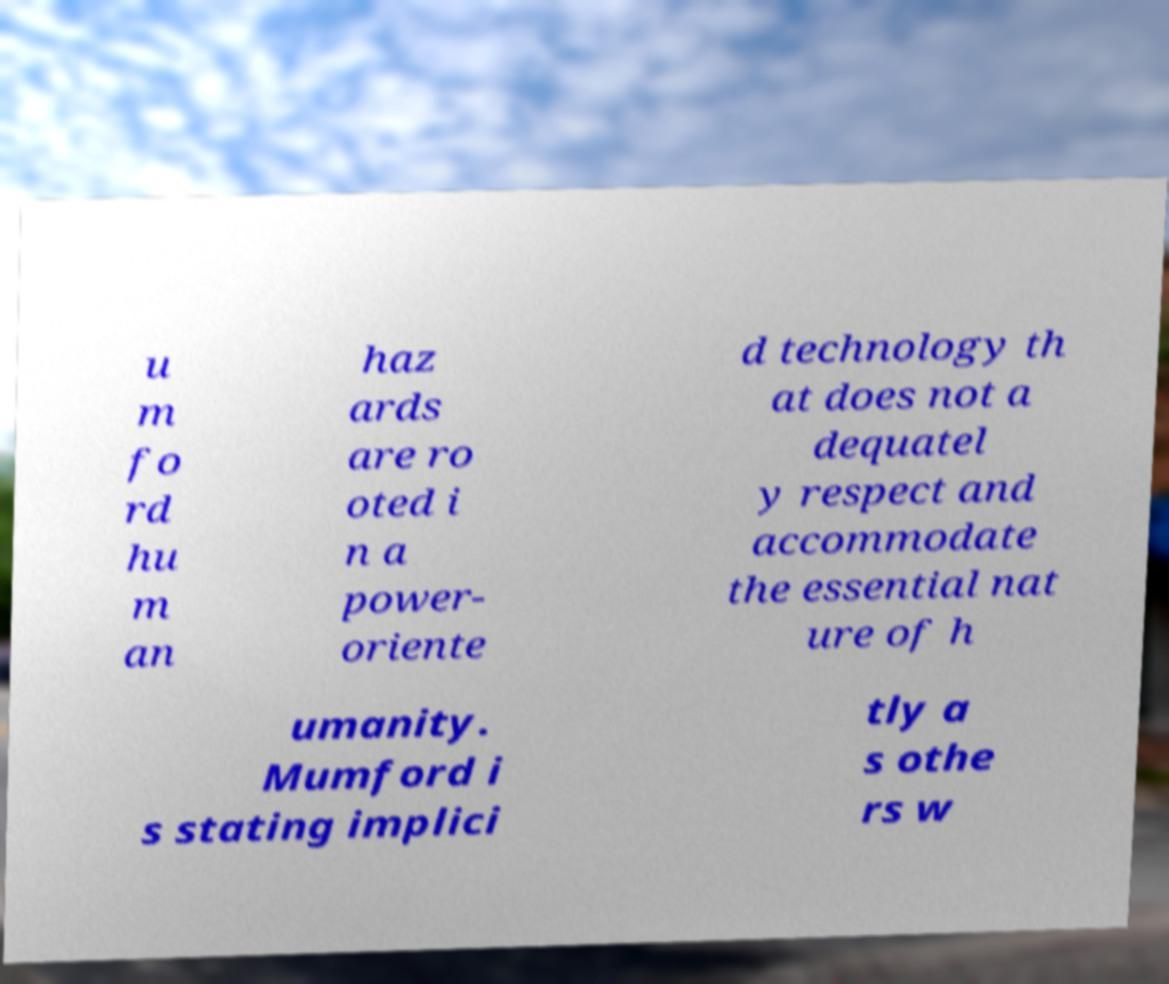Can you read and provide the text displayed in the image?This photo seems to have some interesting text. Can you extract and type it out for me? u m fo rd hu m an haz ards are ro oted i n a power- oriente d technology th at does not a dequatel y respect and accommodate the essential nat ure of h umanity. Mumford i s stating implici tly a s othe rs w 